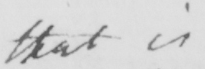Please provide the text content of this handwritten line. that is 